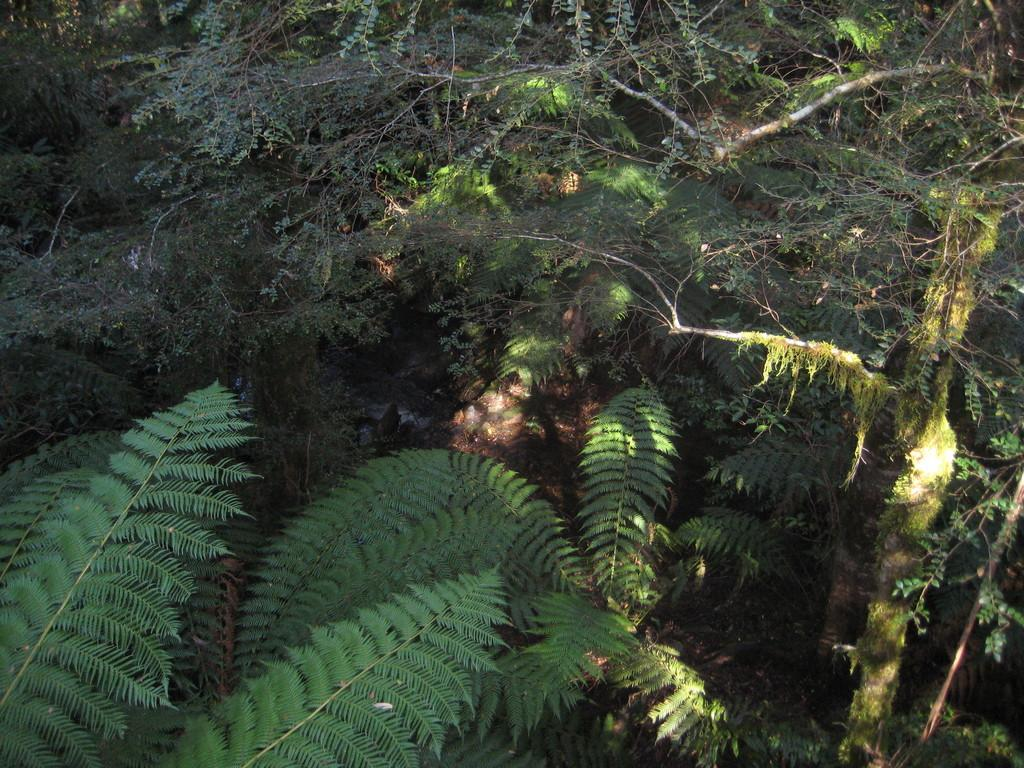What type of vegetation can be seen in the image? There are trees in the image. How are the trees distributed in the image? The trees are around the area of the image. Can you see the writer working on their next novel in the image? There is no writer or any indication of writing or a novel in the image; it features trees. 